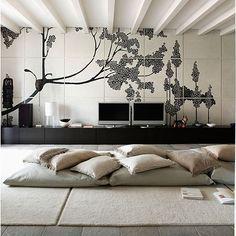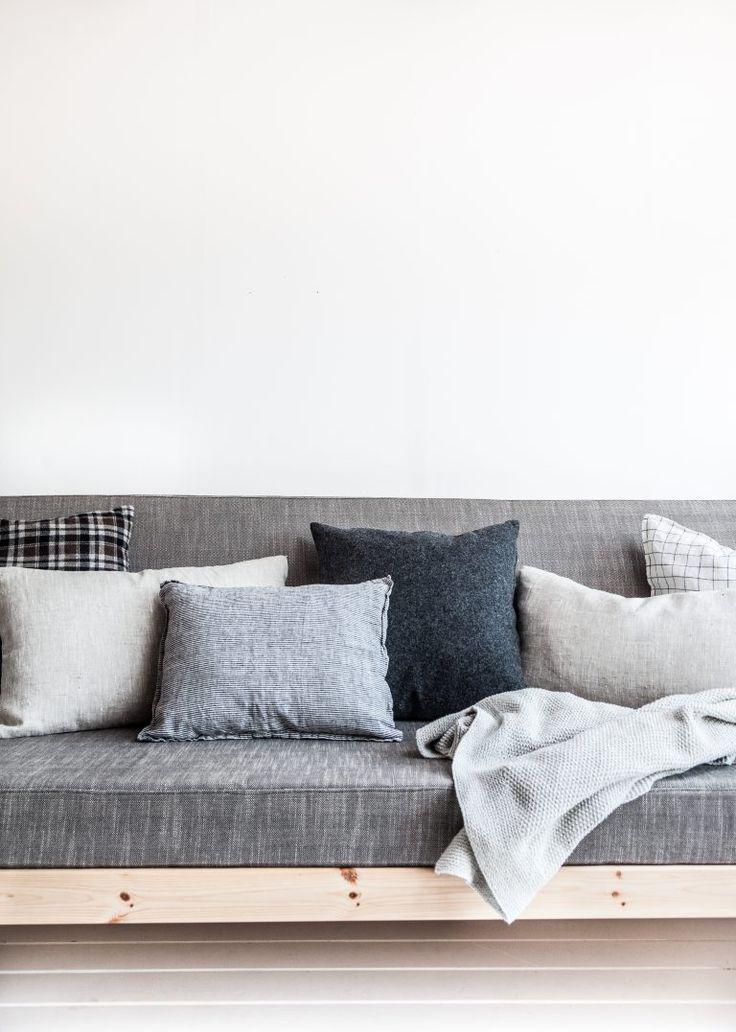The first image is the image on the left, the second image is the image on the right. For the images shown, is this caption "there is a table lamp on the right image" true? Answer yes or no. No. 